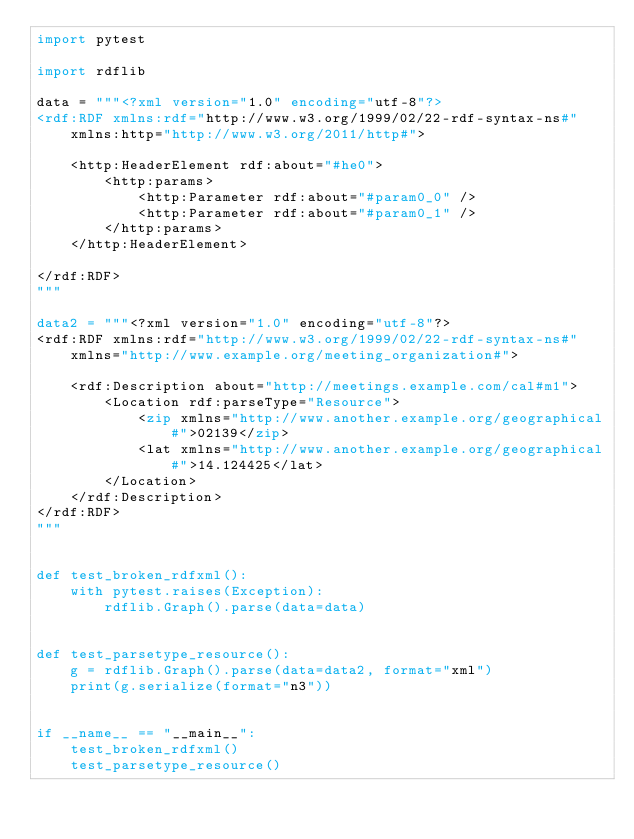<code> <loc_0><loc_0><loc_500><loc_500><_Python_>import pytest

import rdflib

data = """<?xml version="1.0" encoding="utf-8"?>
<rdf:RDF xmlns:rdf="http://www.w3.org/1999/02/22-rdf-syntax-ns#"
    xmlns:http="http://www.w3.org/2011/http#">

    <http:HeaderElement rdf:about="#he0">
        <http:params>
            <http:Parameter rdf:about="#param0_0" />
            <http:Parameter rdf:about="#param0_1" />
        </http:params>
    </http:HeaderElement>

</rdf:RDF>
"""

data2 = """<?xml version="1.0" encoding="utf-8"?>
<rdf:RDF xmlns:rdf="http://www.w3.org/1999/02/22-rdf-syntax-ns#"
    xmlns="http://www.example.org/meeting_organization#">

    <rdf:Description about="http://meetings.example.com/cal#m1">
        <Location rdf:parseType="Resource">
            <zip xmlns="http://www.another.example.org/geographical#">02139</zip>
            <lat xmlns="http://www.another.example.org/geographical#">14.124425</lat>
        </Location>
    </rdf:Description>
</rdf:RDF>
"""


def test_broken_rdfxml():
    with pytest.raises(Exception):
        rdflib.Graph().parse(data=data)


def test_parsetype_resource():
    g = rdflib.Graph().parse(data=data2, format="xml")
    print(g.serialize(format="n3"))


if __name__ == "__main__":
    test_broken_rdfxml()
    test_parsetype_resource()
</code> 